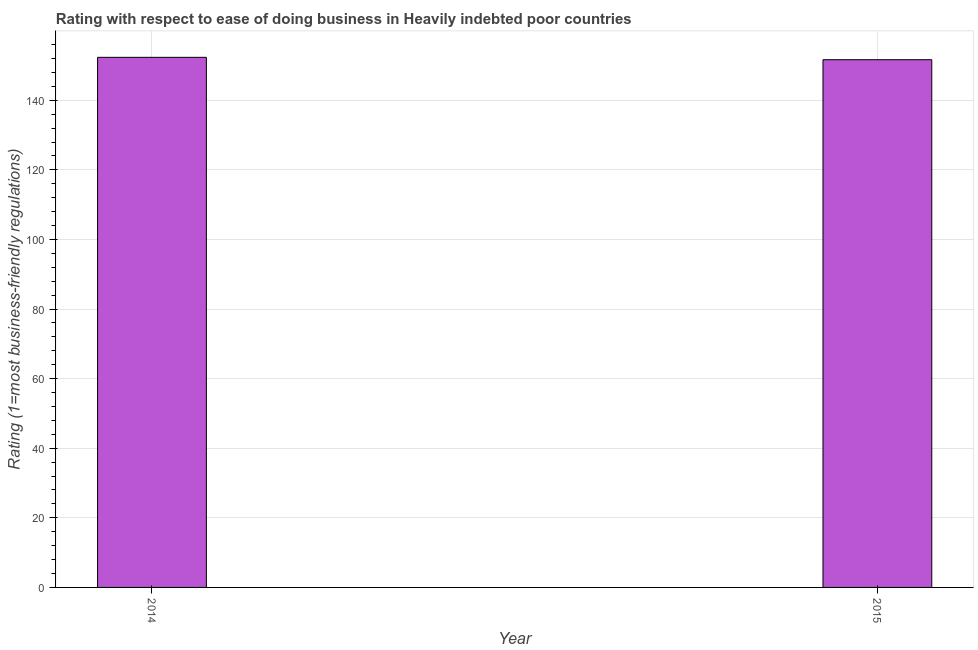Does the graph contain any zero values?
Offer a terse response. No. Does the graph contain grids?
Offer a terse response. Yes. What is the title of the graph?
Offer a terse response. Rating with respect to ease of doing business in Heavily indebted poor countries. What is the label or title of the X-axis?
Provide a succinct answer. Year. What is the label or title of the Y-axis?
Provide a short and direct response. Rating (1=most business-friendly regulations). What is the ease of doing business index in 2015?
Your answer should be compact. 151.66. Across all years, what is the maximum ease of doing business index?
Your answer should be compact. 152.34. Across all years, what is the minimum ease of doing business index?
Provide a short and direct response. 151.66. In which year was the ease of doing business index maximum?
Ensure brevity in your answer.  2014. In which year was the ease of doing business index minimum?
Your answer should be compact. 2015. What is the sum of the ease of doing business index?
Ensure brevity in your answer.  304. What is the difference between the ease of doing business index in 2014 and 2015?
Your answer should be compact. 0.68. What is the average ease of doing business index per year?
Keep it short and to the point. 152. What is the median ease of doing business index?
Your answer should be compact. 152. What is the ratio of the ease of doing business index in 2014 to that in 2015?
Your answer should be very brief. 1. Is the ease of doing business index in 2014 less than that in 2015?
Your answer should be compact. No. How many bars are there?
Provide a short and direct response. 2. Are all the bars in the graph horizontal?
Your answer should be compact. No. How many years are there in the graph?
Make the answer very short. 2. What is the difference between two consecutive major ticks on the Y-axis?
Provide a short and direct response. 20. Are the values on the major ticks of Y-axis written in scientific E-notation?
Make the answer very short. No. What is the Rating (1=most business-friendly regulations) of 2014?
Keep it short and to the point. 152.34. What is the Rating (1=most business-friendly regulations) in 2015?
Provide a succinct answer. 151.66. What is the difference between the Rating (1=most business-friendly regulations) in 2014 and 2015?
Provide a succinct answer. 0.68. 